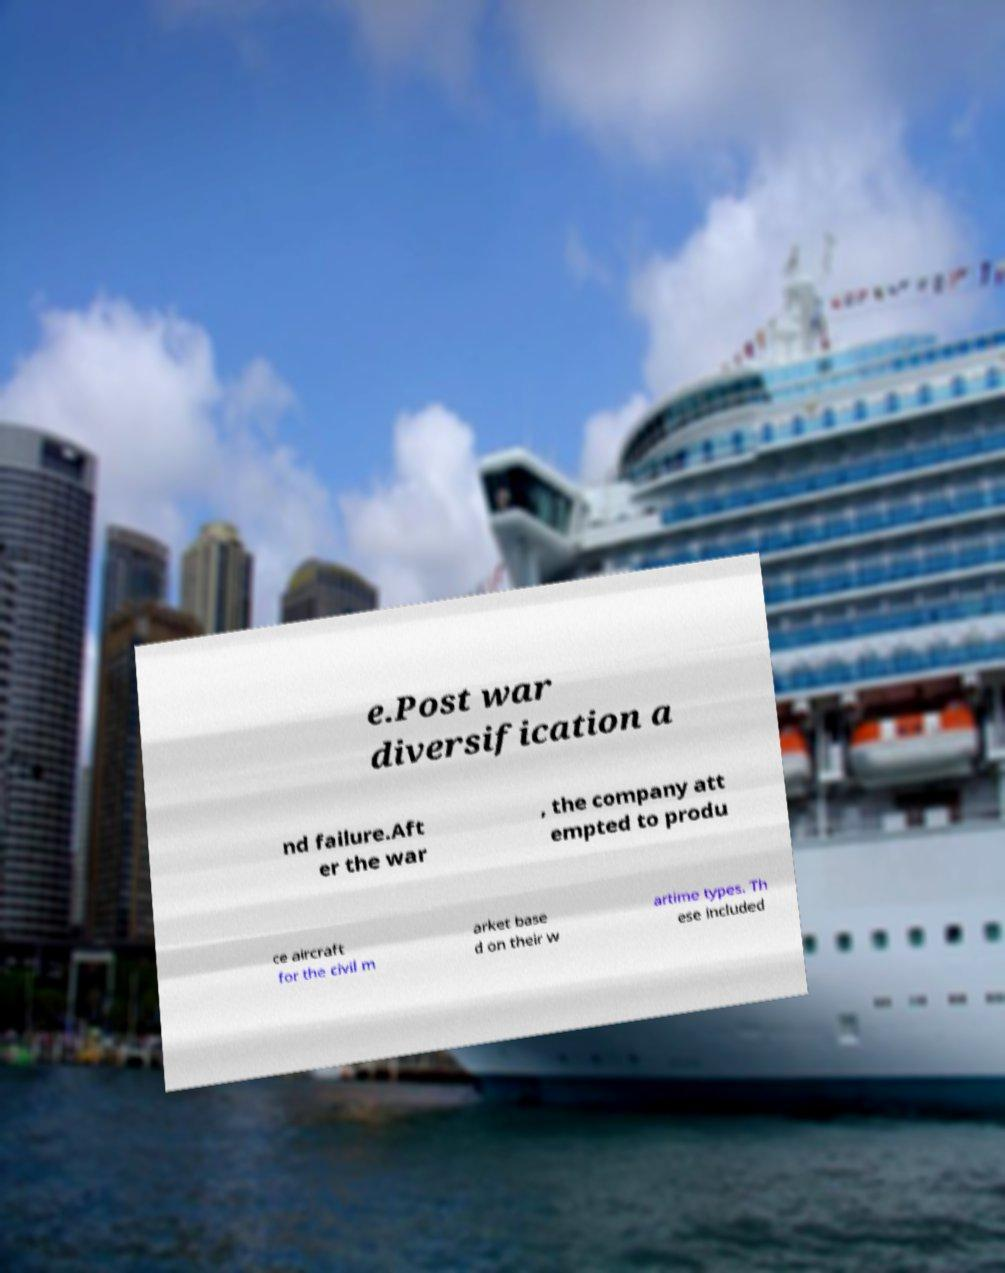There's text embedded in this image that I need extracted. Can you transcribe it verbatim? e.Post war diversification a nd failure.Aft er the war , the company att empted to produ ce aircraft for the civil m arket base d on their w artime types. Th ese included 